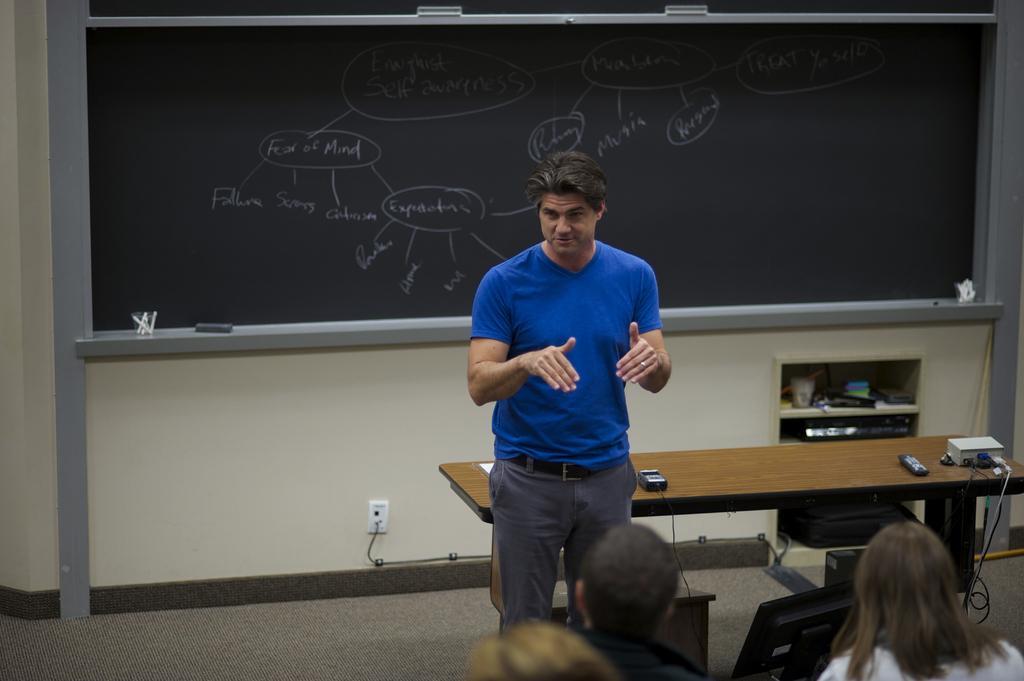Describe this image in one or two sentences. In this image, we can see a person wearing clothes and standing in front of the table. There are some persons in the bottom right of the image. There is board in the middle of the image. 